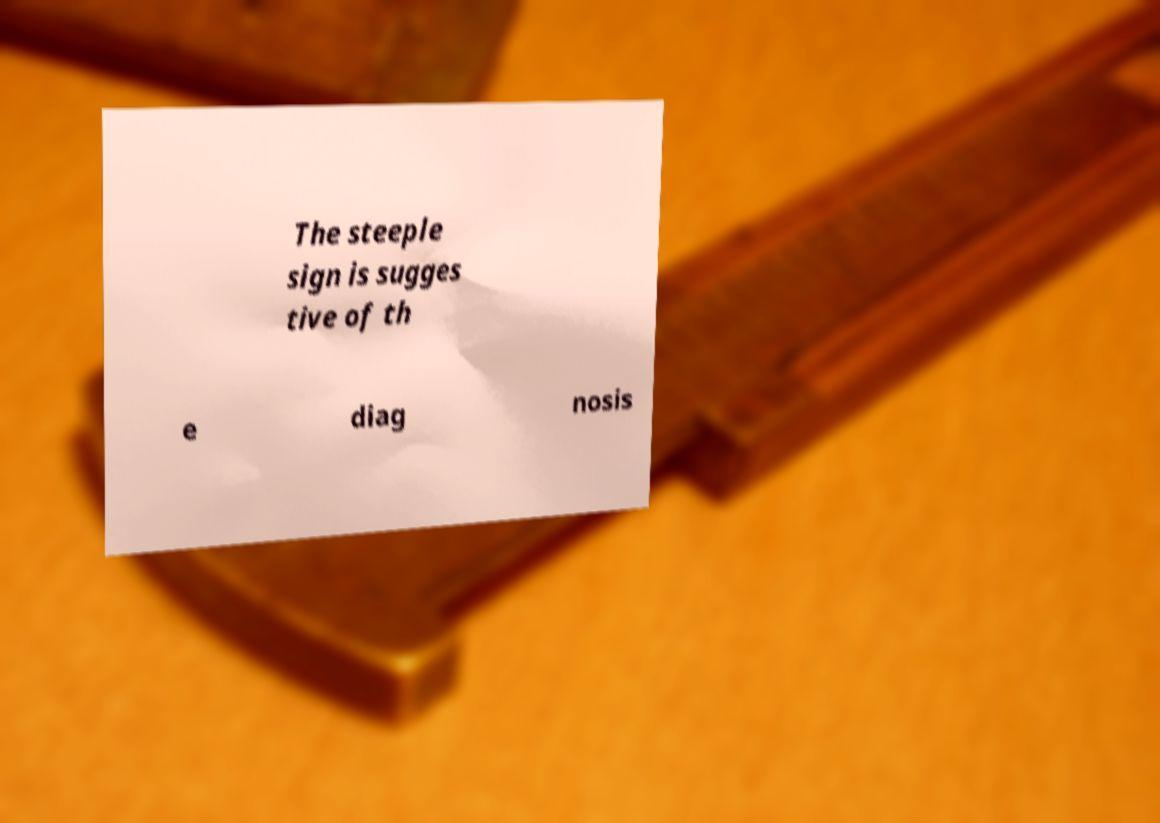What messages or text are displayed in this image? I need them in a readable, typed format. The steeple sign is sugges tive of th e diag nosis 